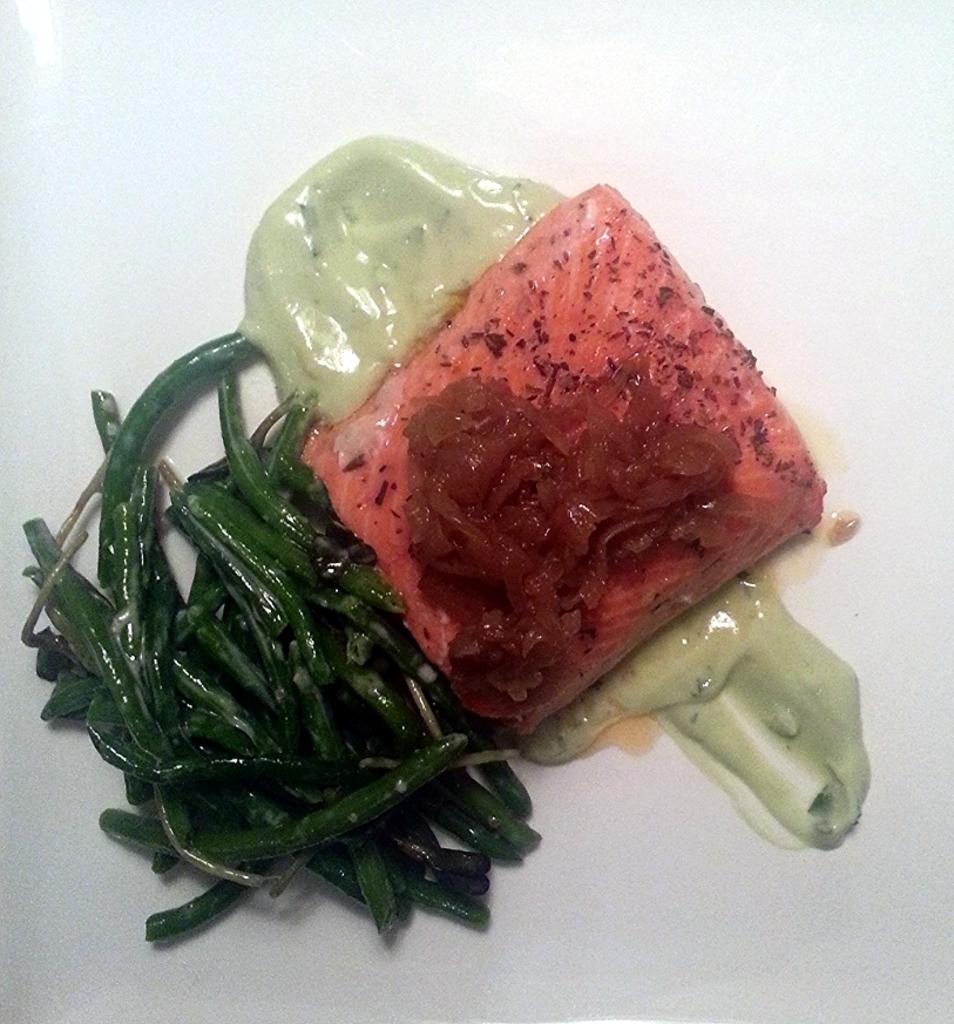What is the main subject of the image? There is a food item in the center of the image. What type of sheet is used to cover the food item in the image? There is no sheet present in the image; it only shows a food item in the center. 